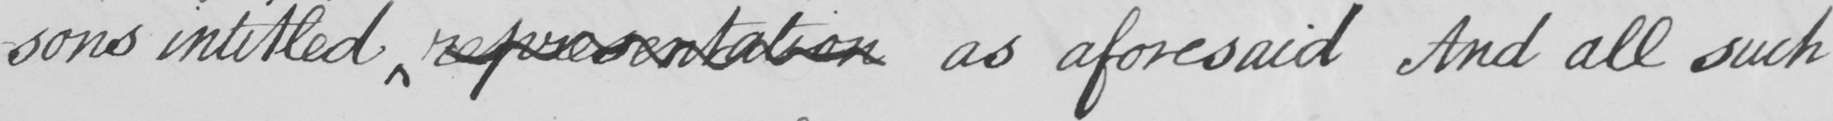What is written in this line of handwriting? -sons intitled representation as aforesaid And all such 